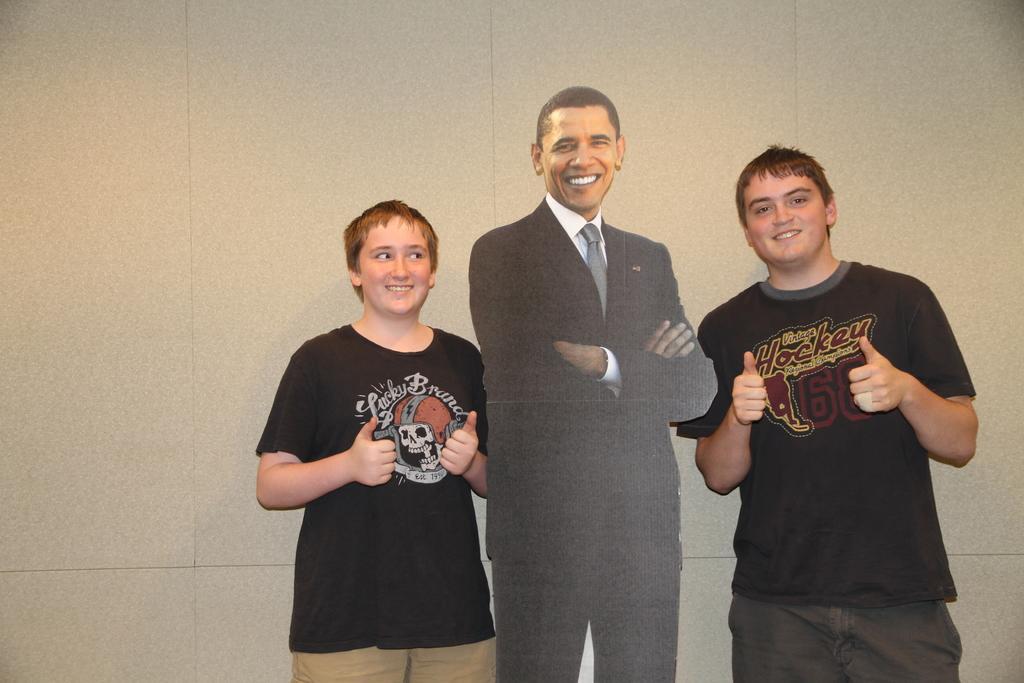Please provide a concise description of this image. In the picture we can see two persons are standing between them, we can see a man poster with a black color blazer and smiling and the two persons are in black T-shirts and smiling and showing their thumbs and behind them we can see a wall. 